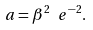Convert formula to latex. <formula><loc_0><loc_0><loc_500><loc_500>a = \beta ^ { 2 } \ e ^ { - 2 } .</formula> 